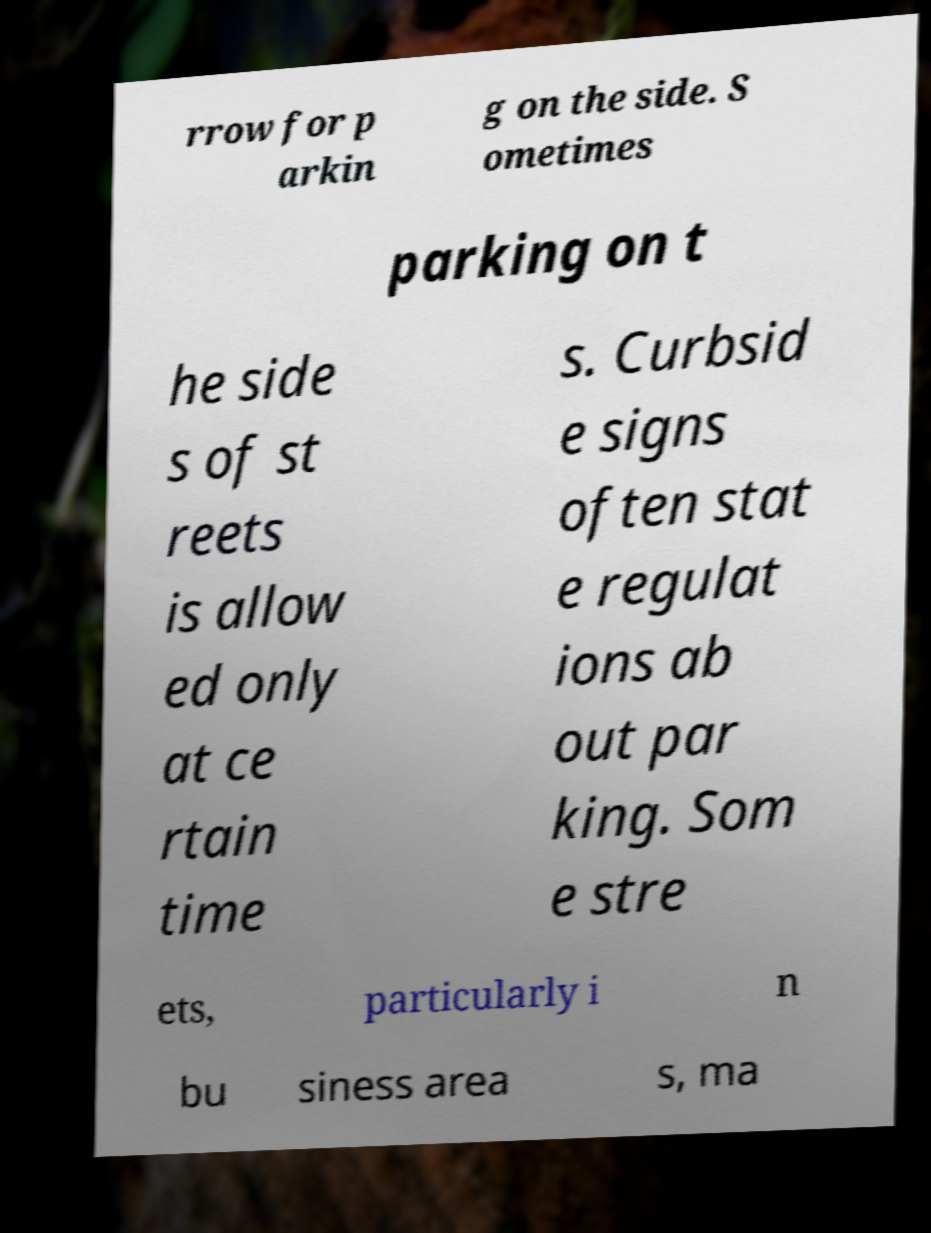Can you accurately transcribe the text from the provided image for me? rrow for p arkin g on the side. S ometimes parking on t he side s of st reets is allow ed only at ce rtain time s. Curbsid e signs often stat e regulat ions ab out par king. Som e stre ets, particularly i n bu siness area s, ma 